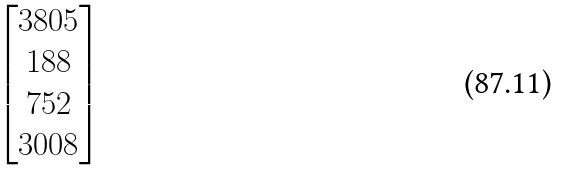<formula> <loc_0><loc_0><loc_500><loc_500>\begin{bmatrix} 3 8 0 5 \\ 1 8 8 \\ 7 5 2 \\ 3 0 0 8 \\ \end{bmatrix}</formula> 